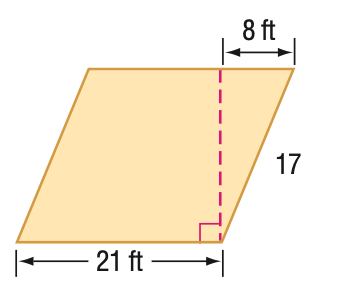Answer the mathemtical geometry problem and directly provide the correct option letter.
Question: Find the area of the parallelogram. Round to the nearest tenth if necessary.
Choices: A: 294 B: 315 C: 336 D: 357 B 